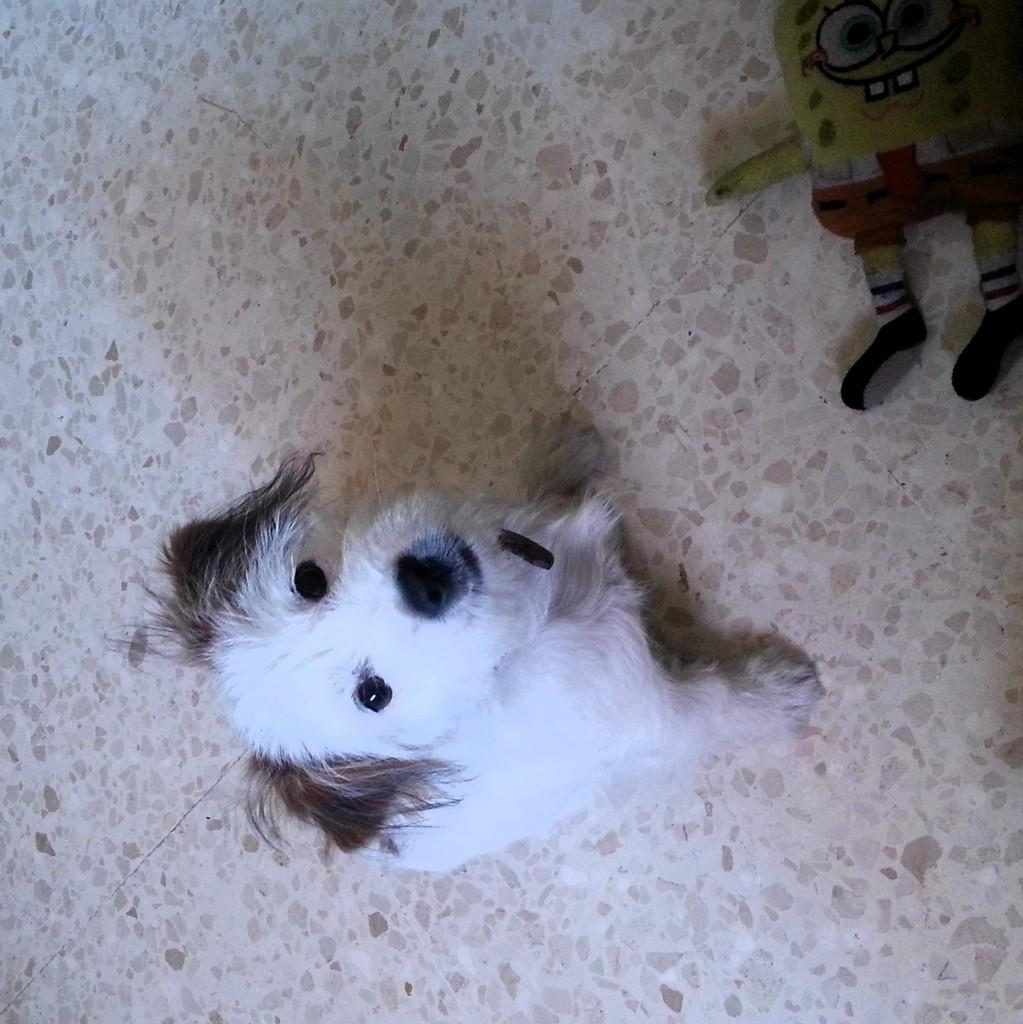What type of animal is in the foreground of the picture? There is a white color dog in the foreground of the picture. What can be seen in the right corner of the image? There is a soft toy in the right corner of the image. Where is the soft toy located in relation to the ground? The soft toy is placed on the ground. What type of pin can be seen holding the dog's fur in the image? There is no pin visible in the image; the dog's fur is not being held by any pin. 